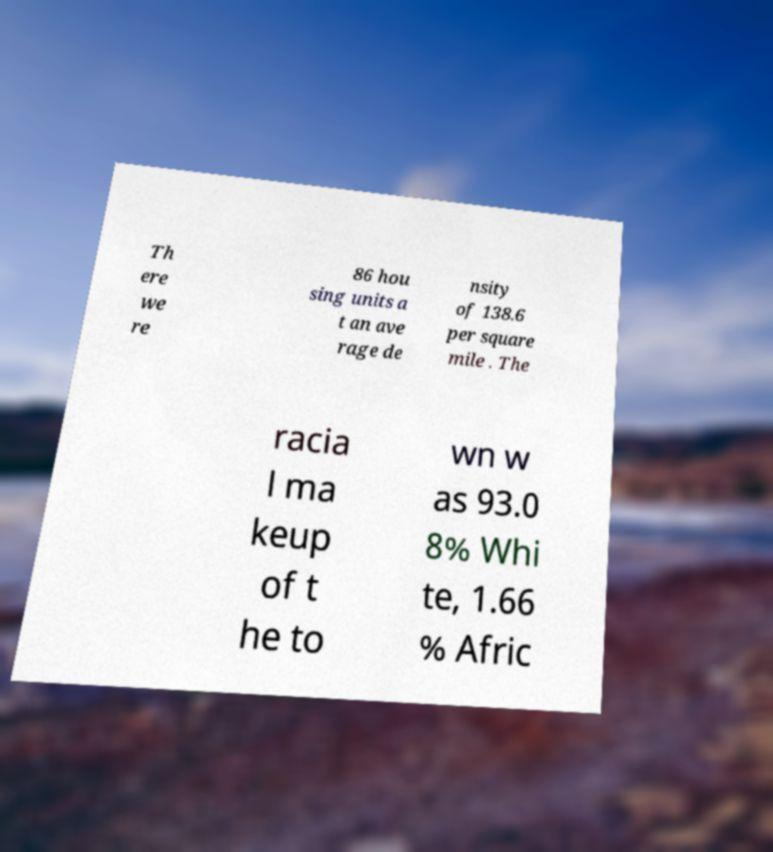Please identify and transcribe the text found in this image. Th ere we re 86 hou sing units a t an ave rage de nsity of 138.6 per square mile . The racia l ma keup of t he to wn w as 93.0 8% Whi te, 1.66 % Afric 